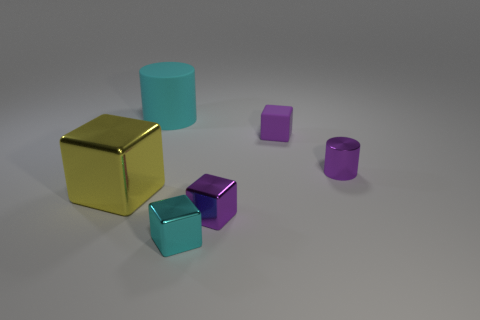Does the rubber thing that is in front of the big cylinder have the same color as the large shiny object?
Provide a short and direct response. No. There is a cube left of the cyan rubber cylinder; is it the same size as the cylinder that is right of the big matte object?
Keep it short and to the point. No. What is the size of the thing that is the same material as the cyan cylinder?
Your response must be concise. Small. How many things are both behind the large metallic cube and in front of the big rubber cylinder?
Ensure brevity in your answer.  2. What number of objects are big matte things or tiny objects that are behind the yellow thing?
Keep it short and to the point. 3. What is the shape of the metal object that is the same color as the small cylinder?
Keep it short and to the point. Cube. The cube that is behind the purple cylinder is what color?
Your answer should be compact. Purple. How many things are either small metal things that are behind the large yellow metallic block or gray metal objects?
Provide a short and direct response. 1. The metal block that is the same size as the rubber cylinder is what color?
Provide a short and direct response. Yellow. Is the number of blocks in front of the big cyan cylinder greater than the number of yellow things?
Your answer should be compact. Yes. 